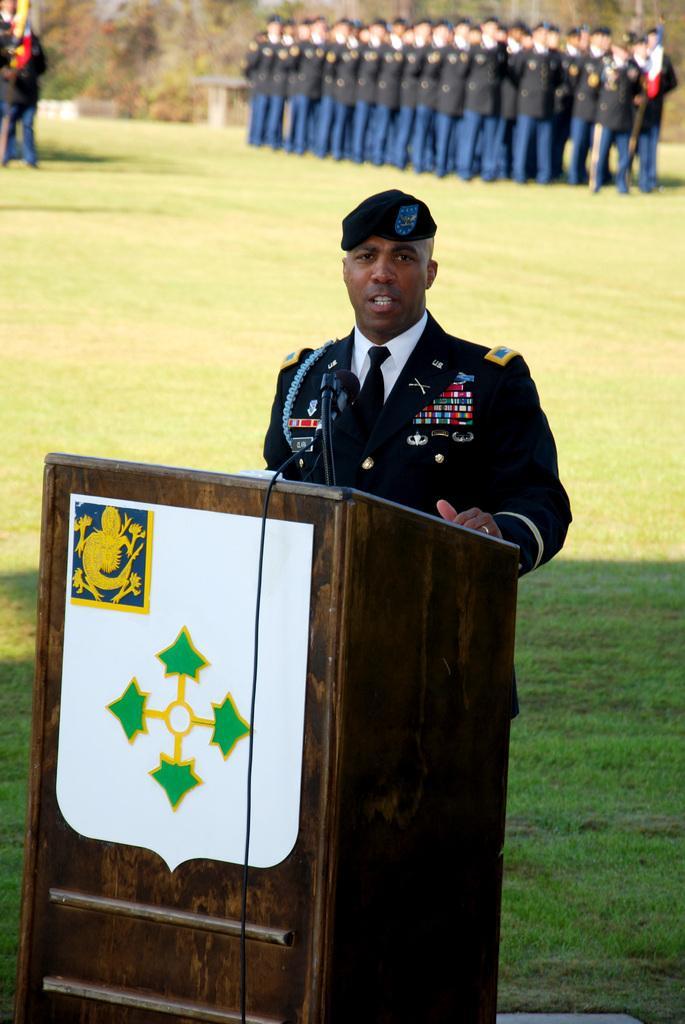Describe this image in one or two sentences. This is the man standing. This looks like a wooden podium with a mike. In the background, I can see a group of people standing. This is the grass. 